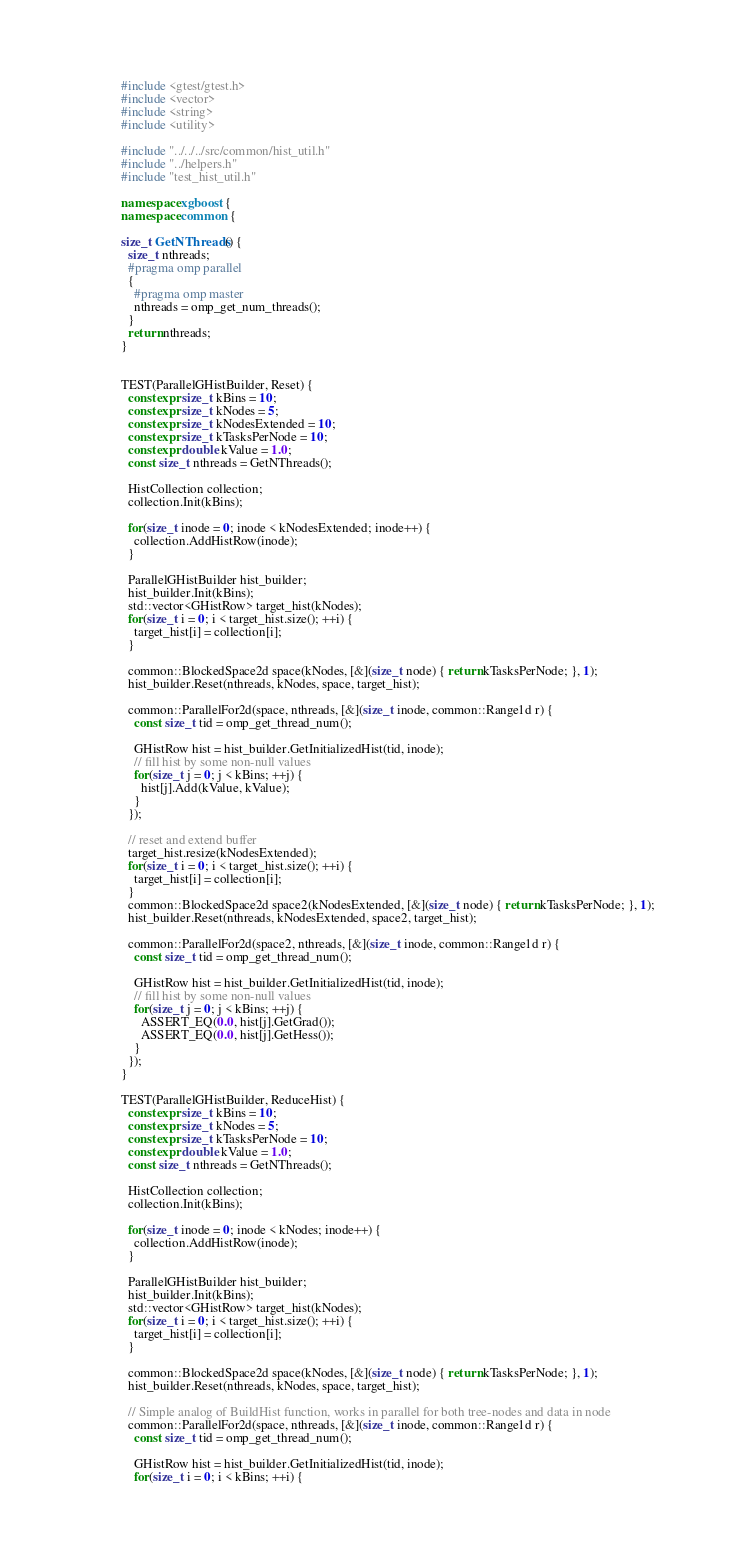<code> <loc_0><loc_0><loc_500><loc_500><_C++_>#include <gtest/gtest.h>
#include <vector>
#include <string>
#include <utility>

#include "../../../src/common/hist_util.h"
#include "../helpers.h"
#include "test_hist_util.h"

namespace xgboost {
namespace common {

size_t GetNThreads() {
  size_t nthreads;
  #pragma omp parallel
  {
    #pragma omp master
    nthreads = omp_get_num_threads();
  }
  return nthreads;
}


TEST(ParallelGHistBuilder, Reset) {
  constexpr size_t kBins = 10;
  constexpr size_t kNodes = 5;
  constexpr size_t kNodesExtended = 10;
  constexpr size_t kTasksPerNode = 10;
  constexpr double kValue = 1.0;
  const size_t nthreads = GetNThreads();

  HistCollection collection;
  collection.Init(kBins);

  for(size_t inode = 0; inode < kNodesExtended; inode++) {
    collection.AddHistRow(inode);
  }

  ParallelGHistBuilder hist_builder;
  hist_builder.Init(kBins);
  std::vector<GHistRow> target_hist(kNodes);
  for(size_t i = 0; i < target_hist.size(); ++i) {
    target_hist[i] = collection[i];
  }

  common::BlockedSpace2d space(kNodes, [&](size_t node) { return kTasksPerNode; }, 1);
  hist_builder.Reset(nthreads, kNodes, space, target_hist);

  common::ParallelFor2d(space, nthreads, [&](size_t inode, common::Range1d r) {
    const size_t tid = omp_get_thread_num();

    GHistRow hist = hist_builder.GetInitializedHist(tid, inode);
    // fill hist by some non-null values
    for(size_t j = 0; j < kBins; ++j) {
      hist[j].Add(kValue, kValue);
    }
  });

  // reset and extend buffer
  target_hist.resize(kNodesExtended);
  for(size_t i = 0; i < target_hist.size(); ++i) {
    target_hist[i] = collection[i];
  }
  common::BlockedSpace2d space2(kNodesExtended, [&](size_t node) { return kTasksPerNode; }, 1);
  hist_builder.Reset(nthreads, kNodesExtended, space2, target_hist);

  common::ParallelFor2d(space2, nthreads, [&](size_t inode, common::Range1d r) {
    const size_t tid = omp_get_thread_num();

    GHistRow hist = hist_builder.GetInitializedHist(tid, inode);
    // fill hist by some non-null values
    for(size_t j = 0; j < kBins; ++j) {
      ASSERT_EQ(0.0, hist[j].GetGrad());
      ASSERT_EQ(0.0, hist[j].GetHess());
    }
  });
}

TEST(ParallelGHistBuilder, ReduceHist) {
  constexpr size_t kBins = 10;
  constexpr size_t kNodes = 5;
  constexpr size_t kTasksPerNode = 10;
  constexpr double kValue = 1.0;
  const size_t nthreads = GetNThreads();

  HistCollection collection;
  collection.Init(kBins);

  for(size_t inode = 0; inode < kNodes; inode++) {
    collection.AddHistRow(inode);
  }

  ParallelGHistBuilder hist_builder;
  hist_builder.Init(kBins);
  std::vector<GHistRow> target_hist(kNodes);
  for(size_t i = 0; i < target_hist.size(); ++i) {
    target_hist[i] = collection[i];
  }

  common::BlockedSpace2d space(kNodes, [&](size_t node) { return kTasksPerNode; }, 1);
  hist_builder.Reset(nthreads, kNodes, space, target_hist);

  // Simple analog of BuildHist function, works in parallel for both tree-nodes and data in node
  common::ParallelFor2d(space, nthreads, [&](size_t inode, common::Range1d r) {
    const size_t tid = omp_get_thread_num();

    GHistRow hist = hist_builder.GetInitializedHist(tid, inode);
    for(size_t i = 0; i < kBins; ++i) {</code> 